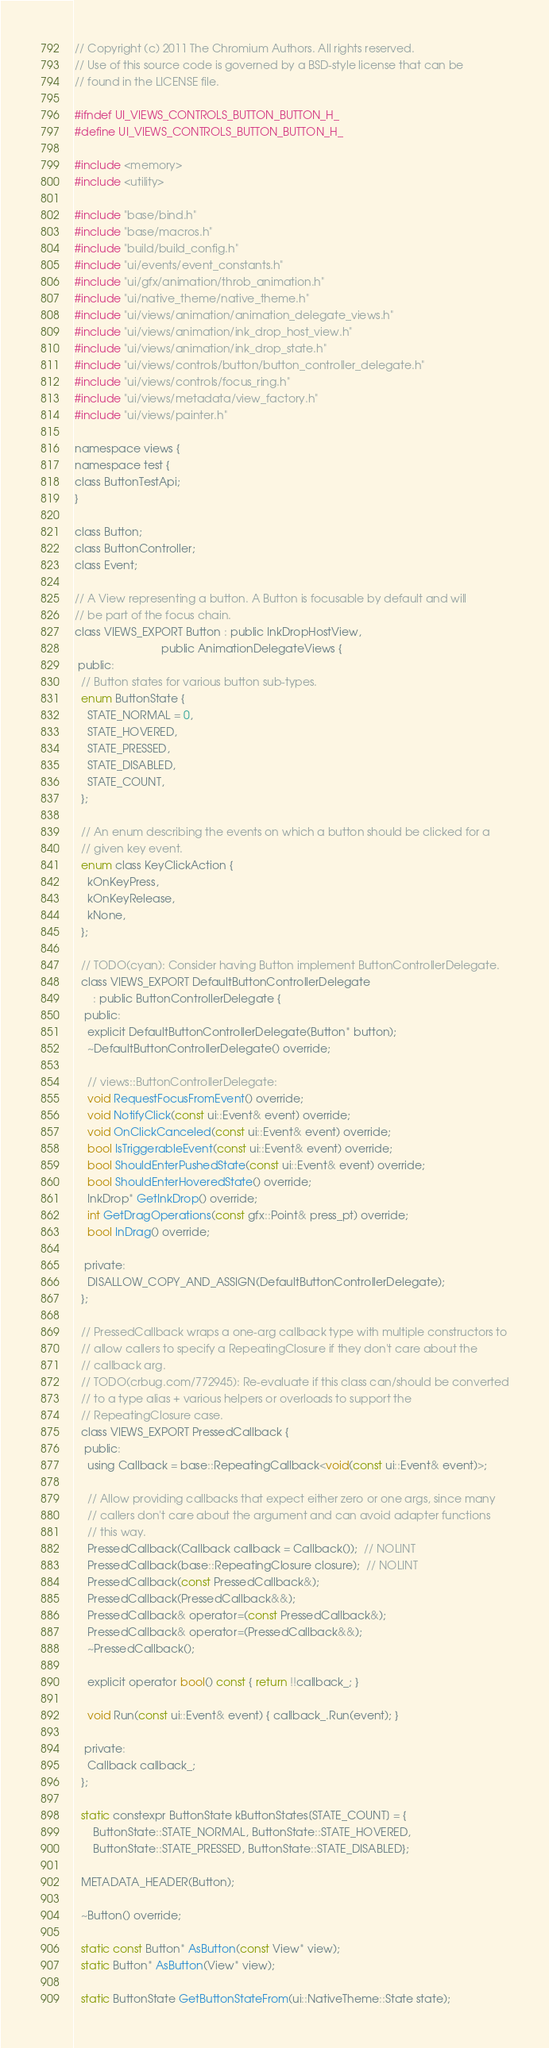<code> <loc_0><loc_0><loc_500><loc_500><_C_>// Copyright (c) 2011 The Chromium Authors. All rights reserved.
// Use of this source code is governed by a BSD-style license that can be
// found in the LICENSE file.

#ifndef UI_VIEWS_CONTROLS_BUTTON_BUTTON_H_
#define UI_VIEWS_CONTROLS_BUTTON_BUTTON_H_

#include <memory>
#include <utility>

#include "base/bind.h"
#include "base/macros.h"
#include "build/build_config.h"
#include "ui/events/event_constants.h"
#include "ui/gfx/animation/throb_animation.h"
#include "ui/native_theme/native_theme.h"
#include "ui/views/animation/animation_delegate_views.h"
#include "ui/views/animation/ink_drop_host_view.h"
#include "ui/views/animation/ink_drop_state.h"
#include "ui/views/controls/button/button_controller_delegate.h"
#include "ui/views/controls/focus_ring.h"
#include "ui/views/metadata/view_factory.h"
#include "ui/views/painter.h"

namespace views {
namespace test {
class ButtonTestApi;
}

class Button;
class ButtonController;
class Event;

// A View representing a button. A Button is focusable by default and will
// be part of the focus chain.
class VIEWS_EXPORT Button : public InkDropHostView,
                            public AnimationDelegateViews {
 public:
  // Button states for various button sub-types.
  enum ButtonState {
    STATE_NORMAL = 0,
    STATE_HOVERED,
    STATE_PRESSED,
    STATE_DISABLED,
    STATE_COUNT,
  };

  // An enum describing the events on which a button should be clicked for a
  // given key event.
  enum class KeyClickAction {
    kOnKeyPress,
    kOnKeyRelease,
    kNone,
  };

  // TODO(cyan): Consider having Button implement ButtonControllerDelegate.
  class VIEWS_EXPORT DefaultButtonControllerDelegate
      : public ButtonControllerDelegate {
   public:
    explicit DefaultButtonControllerDelegate(Button* button);
    ~DefaultButtonControllerDelegate() override;

    // views::ButtonControllerDelegate:
    void RequestFocusFromEvent() override;
    void NotifyClick(const ui::Event& event) override;
    void OnClickCanceled(const ui::Event& event) override;
    bool IsTriggerableEvent(const ui::Event& event) override;
    bool ShouldEnterPushedState(const ui::Event& event) override;
    bool ShouldEnterHoveredState() override;
    InkDrop* GetInkDrop() override;
    int GetDragOperations(const gfx::Point& press_pt) override;
    bool InDrag() override;

   private:
    DISALLOW_COPY_AND_ASSIGN(DefaultButtonControllerDelegate);
  };

  // PressedCallback wraps a one-arg callback type with multiple constructors to
  // allow callers to specify a RepeatingClosure if they don't care about the
  // callback arg.
  // TODO(crbug.com/772945): Re-evaluate if this class can/should be converted
  // to a type alias + various helpers or overloads to support the
  // RepeatingClosure case.
  class VIEWS_EXPORT PressedCallback {
   public:
    using Callback = base::RepeatingCallback<void(const ui::Event& event)>;

    // Allow providing callbacks that expect either zero or one args, since many
    // callers don't care about the argument and can avoid adapter functions
    // this way.
    PressedCallback(Callback callback = Callback());  // NOLINT
    PressedCallback(base::RepeatingClosure closure);  // NOLINT
    PressedCallback(const PressedCallback&);
    PressedCallback(PressedCallback&&);
    PressedCallback& operator=(const PressedCallback&);
    PressedCallback& operator=(PressedCallback&&);
    ~PressedCallback();

    explicit operator bool() const { return !!callback_; }

    void Run(const ui::Event& event) { callback_.Run(event); }

   private:
    Callback callback_;
  };

  static constexpr ButtonState kButtonStates[STATE_COUNT] = {
      ButtonState::STATE_NORMAL, ButtonState::STATE_HOVERED,
      ButtonState::STATE_PRESSED, ButtonState::STATE_DISABLED};

  METADATA_HEADER(Button);

  ~Button() override;

  static const Button* AsButton(const View* view);
  static Button* AsButton(View* view);

  static ButtonState GetButtonStateFrom(ui::NativeTheme::State state);
</code> 